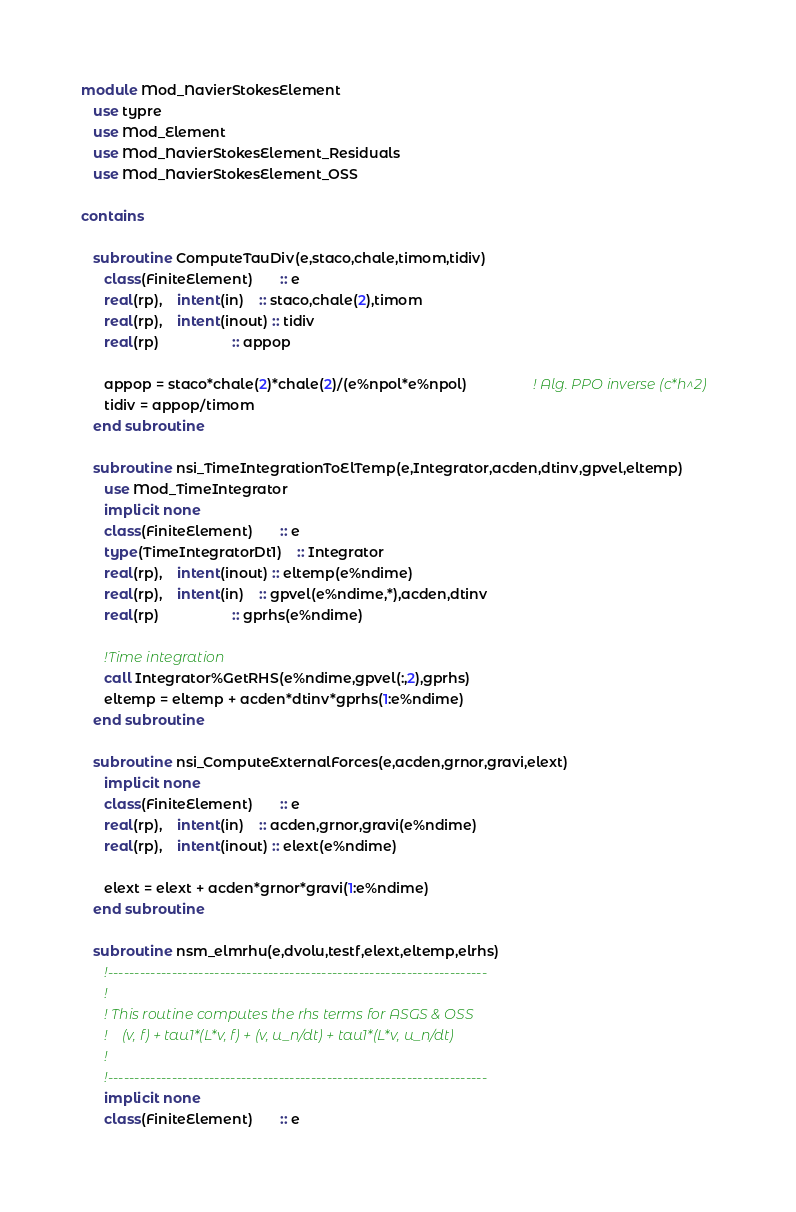<code> <loc_0><loc_0><loc_500><loc_500><_FORTRAN_>module Mod_NavierStokesElement
   use typre
   use Mod_Element
   use Mod_NavierStokesElement_Residuals
   use Mod_NavierStokesElement_OSS
   
contains
   
   subroutine ComputeTauDiv(e,staco,chale,timom,tidiv)
      class(FiniteElement)       :: e
      real(rp),    intent(in)    :: staco,chale(2),timom
      real(rp),    intent(inout) :: tidiv
      real(rp)                   :: appop

      appop = staco*chale(2)*chale(2)/(e%npol*e%npol)                 ! Alg. PPO inverse (c*h^2)
      tidiv = appop/timom
   end subroutine
   
   subroutine nsi_TimeIntegrationToElTemp(e,Integrator,acden,dtinv,gpvel,eltemp)
      use Mod_TimeIntegrator
      implicit none
      class(FiniteElement)       :: e
      type(TimeIntegratorDt1)    :: Integrator
      real(rp),    intent(inout) :: eltemp(e%ndime)
      real(rp),    intent(in)    :: gpvel(e%ndime,*),acden,dtinv
      real(rp)                   :: gprhs(e%ndime)
      
      !Time integration
      call Integrator%GetRHS(e%ndime,gpvel(:,2),gprhs)
      eltemp = eltemp + acden*dtinv*gprhs(1:e%ndime)
   end subroutine
   
   subroutine nsi_ComputeExternalForces(e,acden,grnor,gravi,elext)
      implicit none
      class(FiniteElement)       :: e
      real(rp),    intent(in)    :: acden,grnor,gravi(e%ndime)
      real(rp),    intent(inout) :: elext(e%ndime)
      
      elext = elext + acden*grnor*gravi(1:e%ndime)
   end subroutine
   
   subroutine nsm_elmrhu(e,dvolu,testf,elext,eltemp,elrhs)
      !-----------------------------------------------------------------------
      !
      ! This routine computes the rhs terms for ASGS & OSS
      !    (v, f) + tau1*(L*v, f) + (v, u_n/dt) + tau1*(L*v, u_n/dt)
      !
      !-----------------------------------------------------------------------
      implicit none
      class(FiniteElement)       :: e</code> 